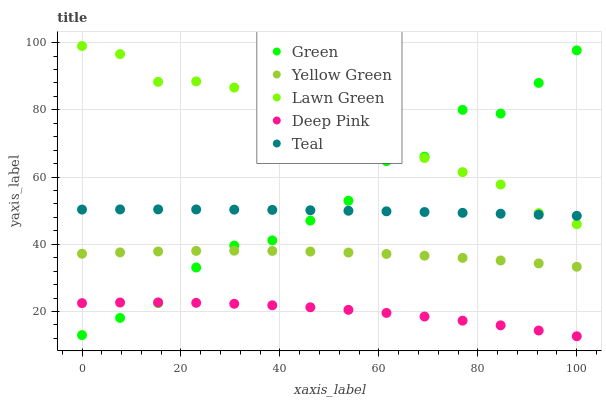Does Deep Pink have the minimum area under the curve?
Answer yes or no. Yes. Does Lawn Green have the maximum area under the curve?
Answer yes or no. Yes. Does Green have the minimum area under the curve?
Answer yes or no. No. Does Green have the maximum area under the curve?
Answer yes or no. No. Is Teal the smoothest?
Answer yes or no. Yes. Is Green the roughest?
Answer yes or no. Yes. Is Deep Pink the smoothest?
Answer yes or no. No. Is Deep Pink the roughest?
Answer yes or no. No. Does Deep Pink have the lowest value?
Answer yes or no. Yes. Does Green have the lowest value?
Answer yes or no. No. Does Lawn Green have the highest value?
Answer yes or no. Yes. Does Green have the highest value?
Answer yes or no. No. Is Deep Pink less than Lawn Green?
Answer yes or no. Yes. Is Teal greater than Yellow Green?
Answer yes or no. Yes. Does Green intersect Yellow Green?
Answer yes or no. Yes. Is Green less than Yellow Green?
Answer yes or no. No. Is Green greater than Yellow Green?
Answer yes or no. No. Does Deep Pink intersect Lawn Green?
Answer yes or no. No. 